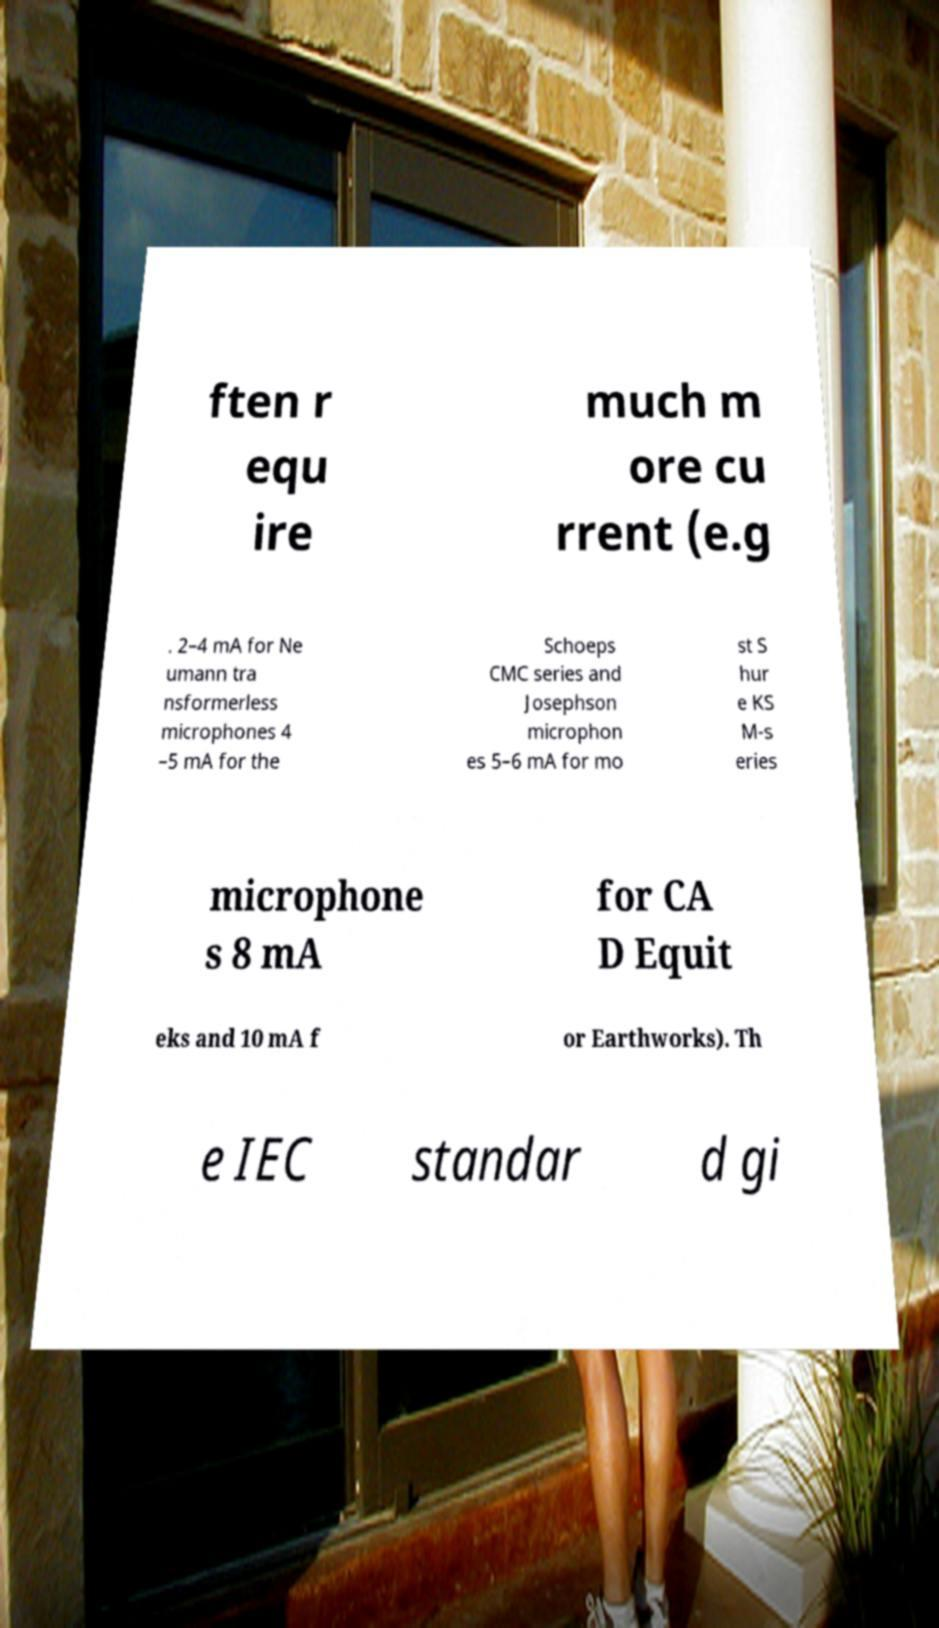I need the written content from this picture converted into text. Can you do that? ften r equ ire much m ore cu rrent (e.g . 2–4 mA for Ne umann tra nsformerless microphones 4 –5 mA for the Schoeps CMC series and Josephson microphon es 5–6 mA for mo st S hur e KS M-s eries microphone s 8 mA for CA D Equit eks and 10 mA f or Earthworks). Th e IEC standar d gi 